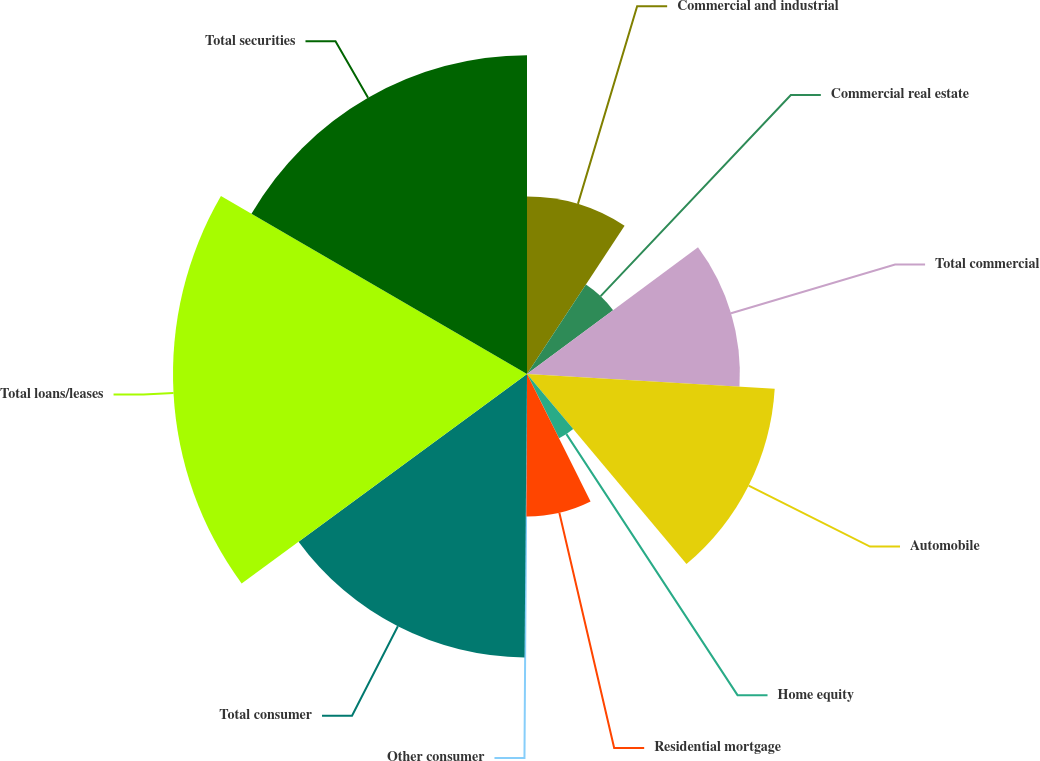<chart> <loc_0><loc_0><loc_500><loc_500><pie_chart><fcel>Commercial and industrial<fcel>Commercial real estate<fcel>Total commercial<fcel>Automobile<fcel>Home equity<fcel>Residential mortgage<fcel>Other consumer<fcel>Total consumer<fcel>Total loans/leases<fcel>Total securities<nl><fcel>9.26%<fcel>5.59%<fcel>11.1%<fcel>12.94%<fcel>3.75%<fcel>7.43%<fcel>0.07%<fcel>14.78%<fcel>18.46%<fcel>16.62%<nl></chart> 